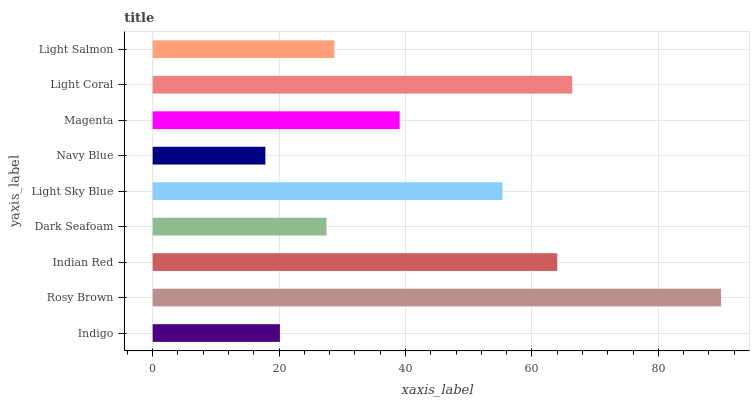Is Navy Blue the minimum?
Answer yes or no. Yes. Is Rosy Brown the maximum?
Answer yes or no. Yes. Is Indian Red the minimum?
Answer yes or no. No. Is Indian Red the maximum?
Answer yes or no. No. Is Rosy Brown greater than Indian Red?
Answer yes or no. Yes. Is Indian Red less than Rosy Brown?
Answer yes or no. Yes. Is Indian Red greater than Rosy Brown?
Answer yes or no. No. Is Rosy Brown less than Indian Red?
Answer yes or no. No. Is Magenta the high median?
Answer yes or no. Yes. Is Magenta the low median?
Answer yes or no. Yes. Is Light Sky Blue the high median?
Answer yes or no. No. Is Rosy Brown the low median?
Answer yes or no. No. 